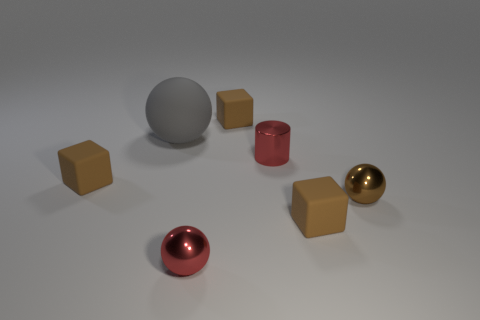Subtract all brown blocks. How many were subtracted if there are1brown blocks left? 2 Subtract all large spheres. How many spheres are left? 2 Subtract all red spheres. How many spheres are left? 2 Subtract all balls. How many objects are left? 4 Add 1 gray objects. How many objects exist? 8 Subtract 2 balls. How many balls are left? 1 Subtract all purple cylinders. How many red balls are left? 1 Subtract all small blue matte cylinders. Subtract all rubber blocks. How many objects are left? 4 Add 3 tiny red shiny cylinders. How many tiny red shiny cylinders are left? 4 Add 4 red metal objects. How many red metal objects exist? 6 